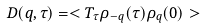<formula> <loc_0><loc_0><loc_500><loc_500>D ( q , \tau ) = < T _ { \tau } \rho _ { - q } ( \tau ) \rho _ { q } ( 0 ) ></formula> 